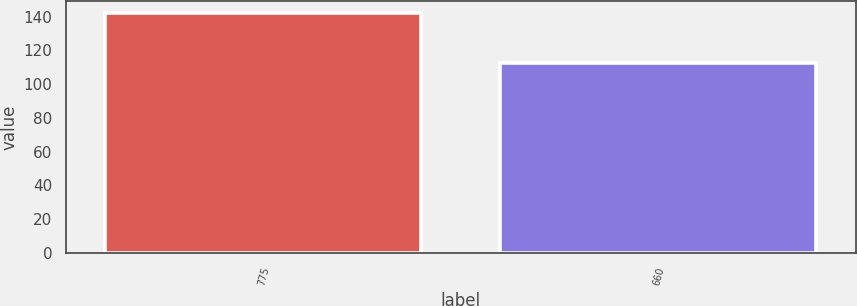Convert chart to OTSL. <chart><loc_0><loc_0><loc_500><loc_500><bar_chart><fcel>775<fcel>660<nl><fcel>142<fcel>112.7<nl></chart> 